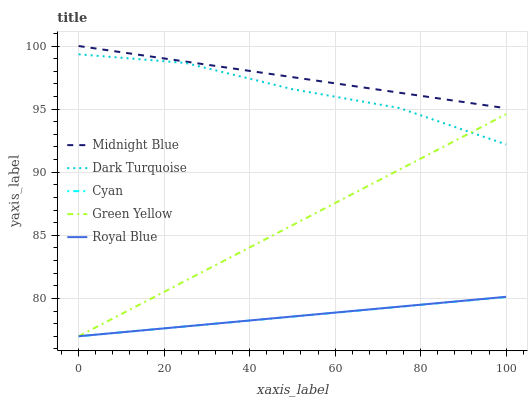Does Green Yellow have the minimum area under the curve?
Answer yes or no. No. Does Green Yellow have the maximum area under the curve?
Answer yes or no. No. Is Green Yellow the smoothest?
Answer yes or no. No. Is Green Yellow the roughest?
Answer yes or no. No. Does Midnight Blue have the lowest value?
Answer yes or no. No. Does Green Yellow have the highest value?
Answer yes or no. No. Is Cyan less than Dark Turquoise?
Answer yes or no. Yes. Is Midnight Blue greater than Green Yellow?
Answer yes or no. Yes. Does Cyan intersect Dark Turquoise?
Answer yes or no. No. 